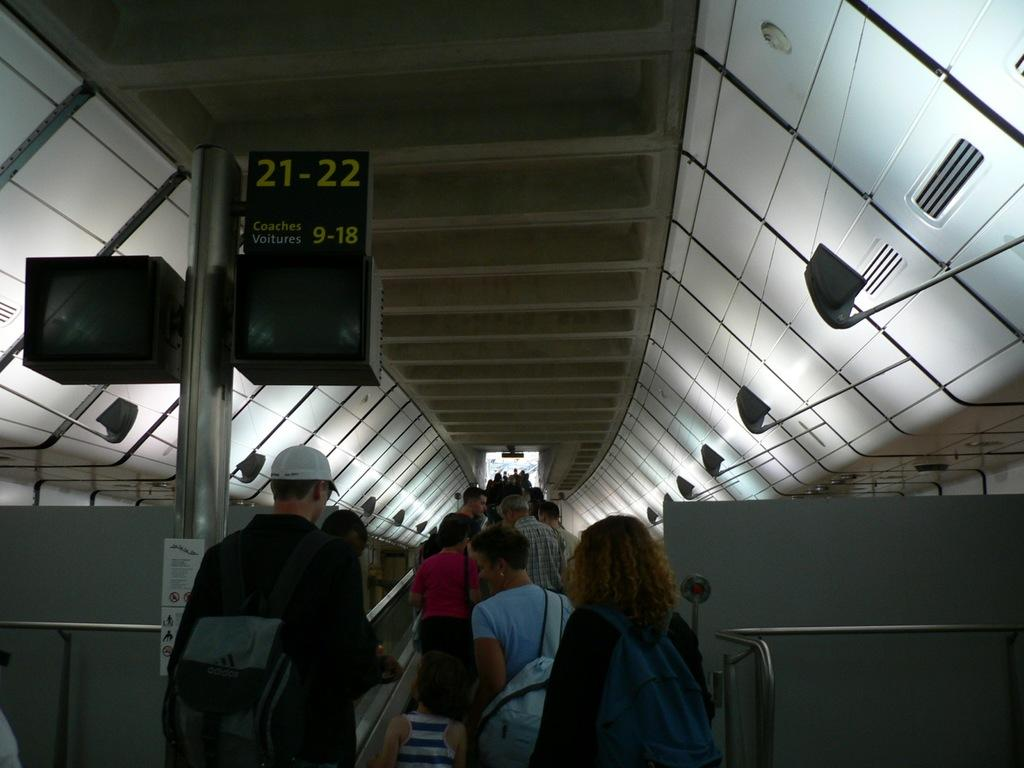What is happening with the group of people in the image? The people are moving through an escalator. Can you describe the board on the left side of the image? Unfortunately, there is no information provided about the board on the left side of the image. What is the primary mode of transportation for the group of people in the image? The primary mode of transportation for the group of people in the image is the escalator. What type of sugar is being used to play the musical instrument in the image? There is no sugar or musical instrument present in the image. What kind of rod can be seen holding up the structure in the image? There is no structure or rod present in the image. 